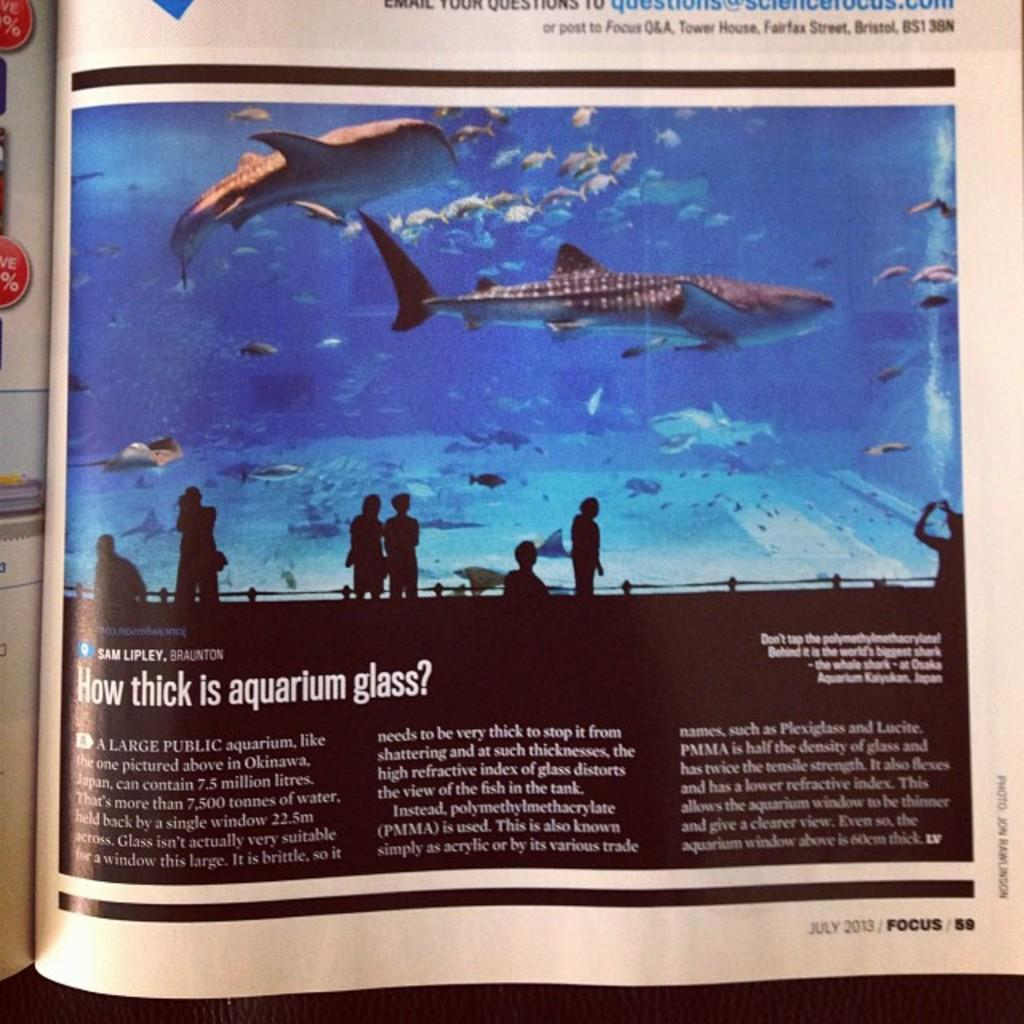What can be seen on the page in the image? There is writing on the page, as well as people and fishes depicted on it. Can you describe the people depicted on the page? Unfortunately, the details of the people depicted on the page cannot be determined from the provided facts. What type of animals are depicted on the page? Fishes are depicted on the page. What type of apparel is being worn by the fishes in the image? There is no mention of apparel or clothing in the image, as it features writing, people, and fishes. Where is the lunchroom located in the image? There is no reference to a lunchroom in the image; it contains writing, people, and fishes. 